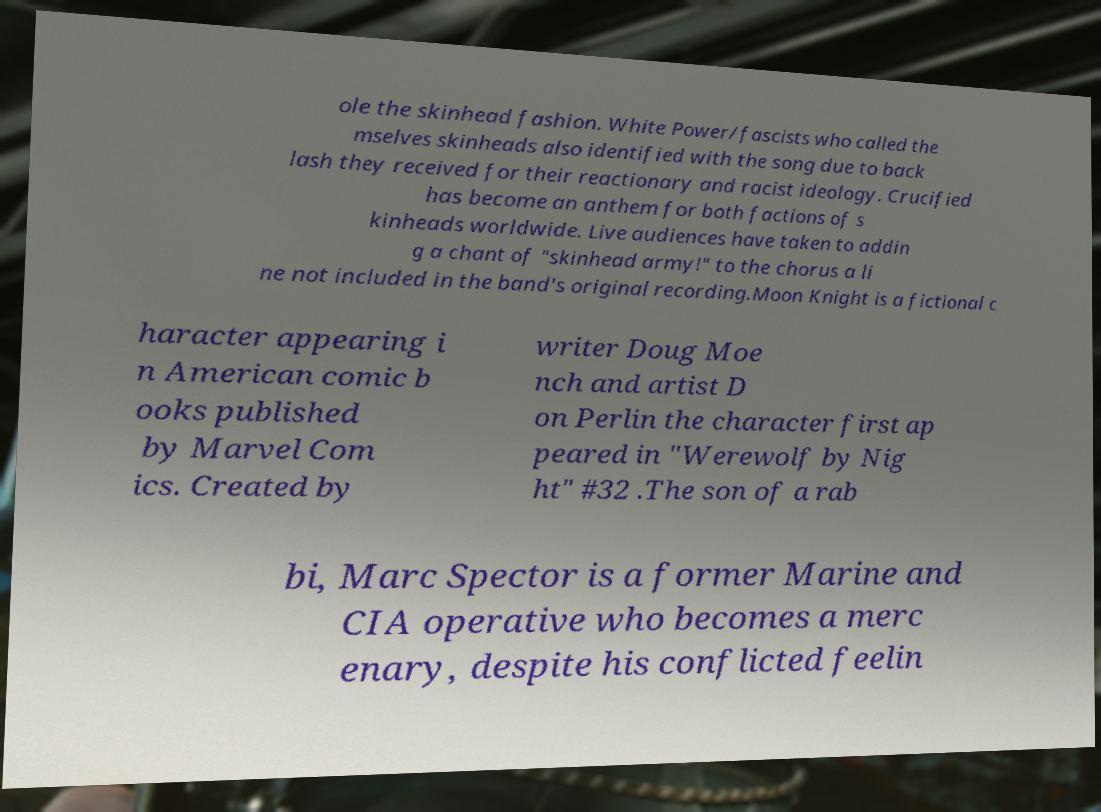Could you extract and type out the text from this image? ole the skinhead fashion. White Power/fascists who called the mselves skinheads also identified with the song due to back lash they received for their reactionary and racist ideology. Crucified has become an anthem for both factions of s kinheads worldwide. Live audiences have taken to addin g a chant of "skinhead army!" to the chorus a li ne not included in the band's original recording.Moon Knight is a fictional c haracter appearing i n American comic b ooks published by Marvel Com ics. Created by writer Doug Moe nch and artist D on Perlin the character first ap peared in "Werewolf by Nig ht" #32 .The son of a rab bi, Marc Spector is a former Marine and CIA operative who becomes a merc enary, despite his conflicted feelin 